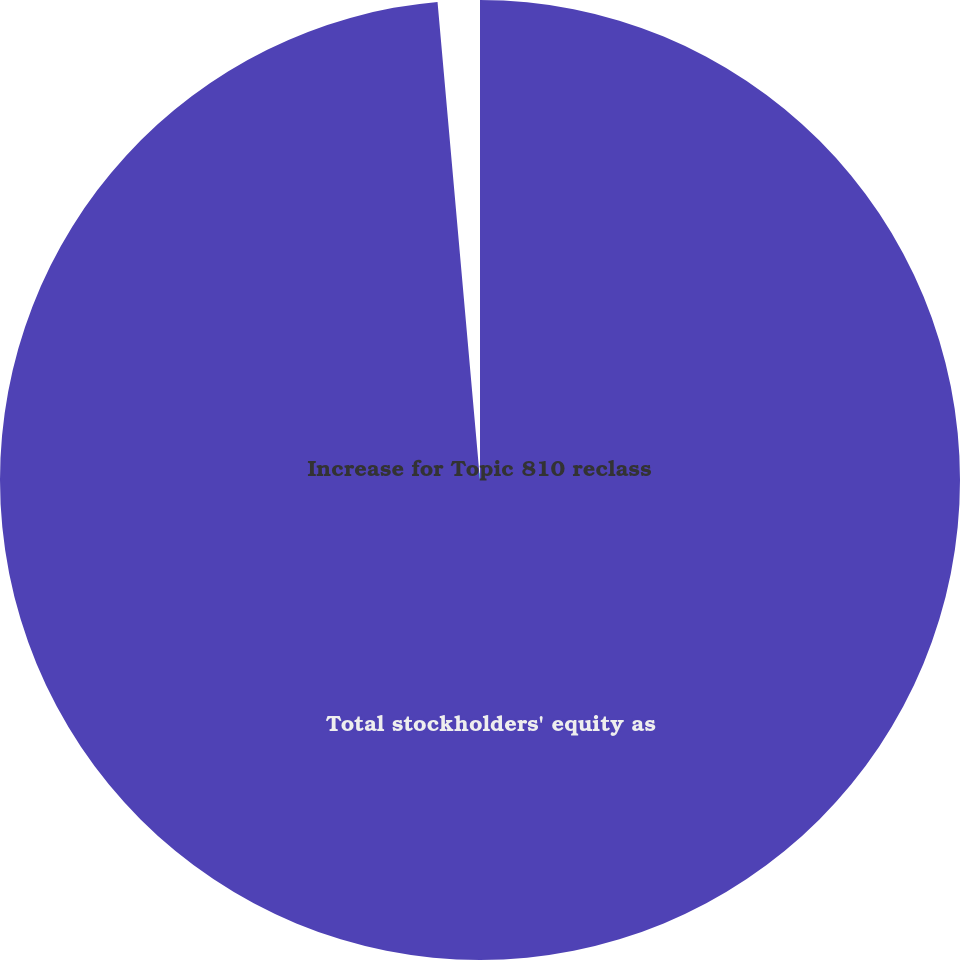<chart> <loc_0><loc_0><loc_500><loc_500><pie_chart><fcel>Total stockholders' equity as<fcel>Increase for Topic 810 reclass<nl><fcel>98.59%<fcel>1.41%<nl></chart> 